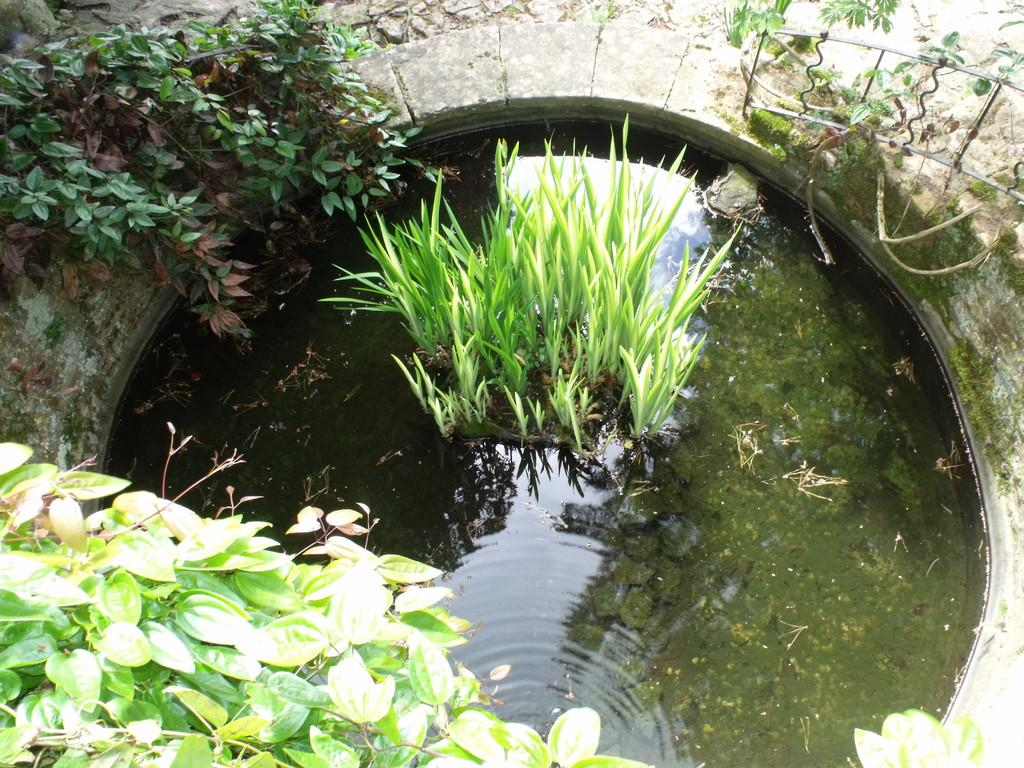What is happening to the plants in the image? The plants are in the water in the image. What can be seen in the background of the image? There are trees visible in the background of the image. What time of day is it in the image, and how does the cow contribute to the scene? There is no cow present in the image, and the time of day cannot be determined from the provided facts. 